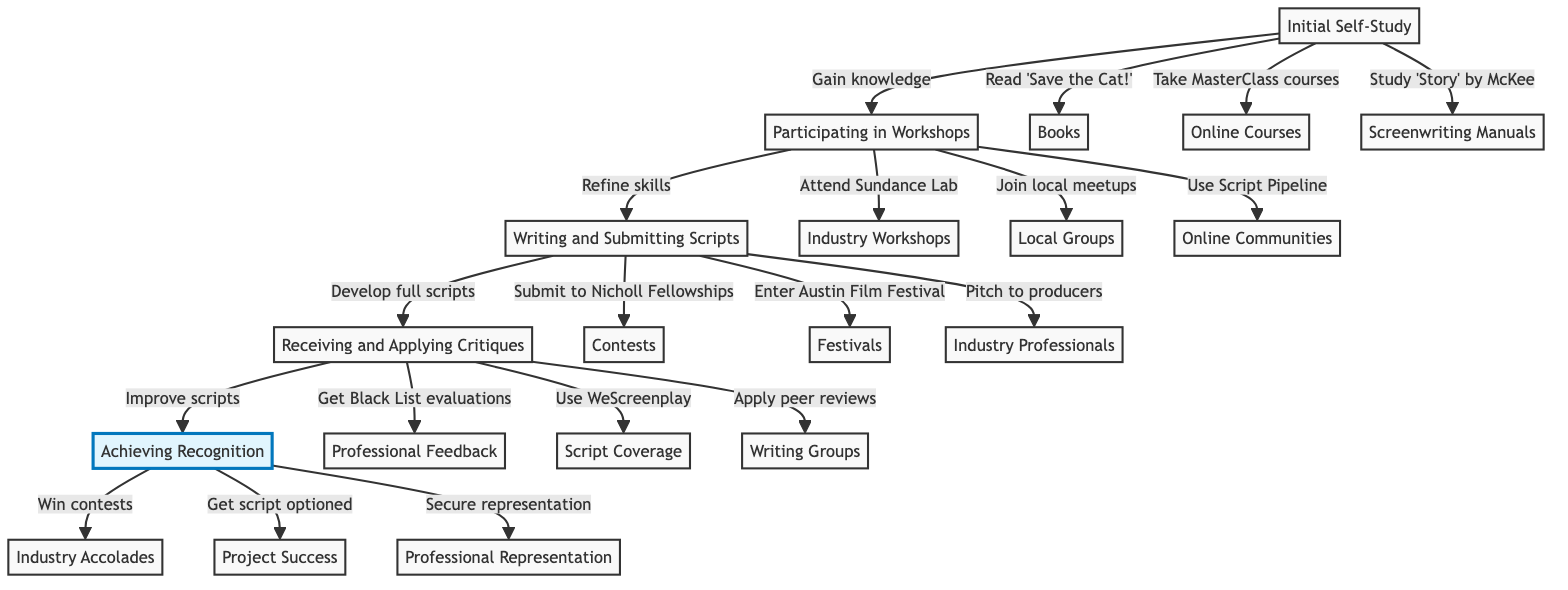What is the first stage in the diagram? The diagram shows the flow starting from "Initial Self-Study," which is the first stage listed at the bottom.
Answer: Initial Self-Study How many main stages are there in the journey to professional recognition? There are five main stages represented in the diagram: Initial Self-Study, Participating in Workshops, Writing and Submitting Scripts, Receiving and Applying Critiques, and Achieving Recognition.
Answer: Five What does the arrow from "Participating in Workshops" to "Writing and Submitting Scripts" signify? The arrow indicates that "Participating in Workshops" leads to "Writing and Submitting Scripts," suggesting that refining skills through workshops is necessary before developing and submitting scripts.
Answer: Leads to Which stage is immediately before "Receiving and Applying Critiques"? The stage that comes immediately before "Receiving and Applying Critiques" is "Writing and Submitting Scripts," indicating they are directly connected in sequence.
Answer: Writing and Submitting Scripts What type of feedback is associated with "Receiving and Applying Critiques"? The feedback associated with this stage includes evaluations and notes gathered from various sources, such as contests, professionals, and peer reviews, emphasizing its focus on improving scripts.
Answer: Professional Feedback What can be gained from the "Achieving Recognition" stage? From "Achieving Recognition," one can gain accolades and success in the industry, including winning contests and having scripts optioned by production companies.
Answer: Industry Accolades What is the last step in the journey depicted in the diagram? The last step in the journey is "Achieving Recognition," which signifies reaching a level of acknowledgment in the industry after following the earlier stages.
Answer: Achieving Recognition Which stage involves "Submitting to Nicholl Fellowships"? The stage that involves "Submitting to Nicholl Fellowships" is "Writing and Submitting Scripts," highlighting one method of getting scripts submitted for consideration.
Answer: Writing and Submitting Scripts How does "Initial Self-Study" relate to "Participating in Workshops"? "Initial Self-Study" provides foundational knowledge that facilitates the next stage, "Participating in Workshops," thereby creating a dependency on prior learning for further development.
Answer: Gain knowledge 